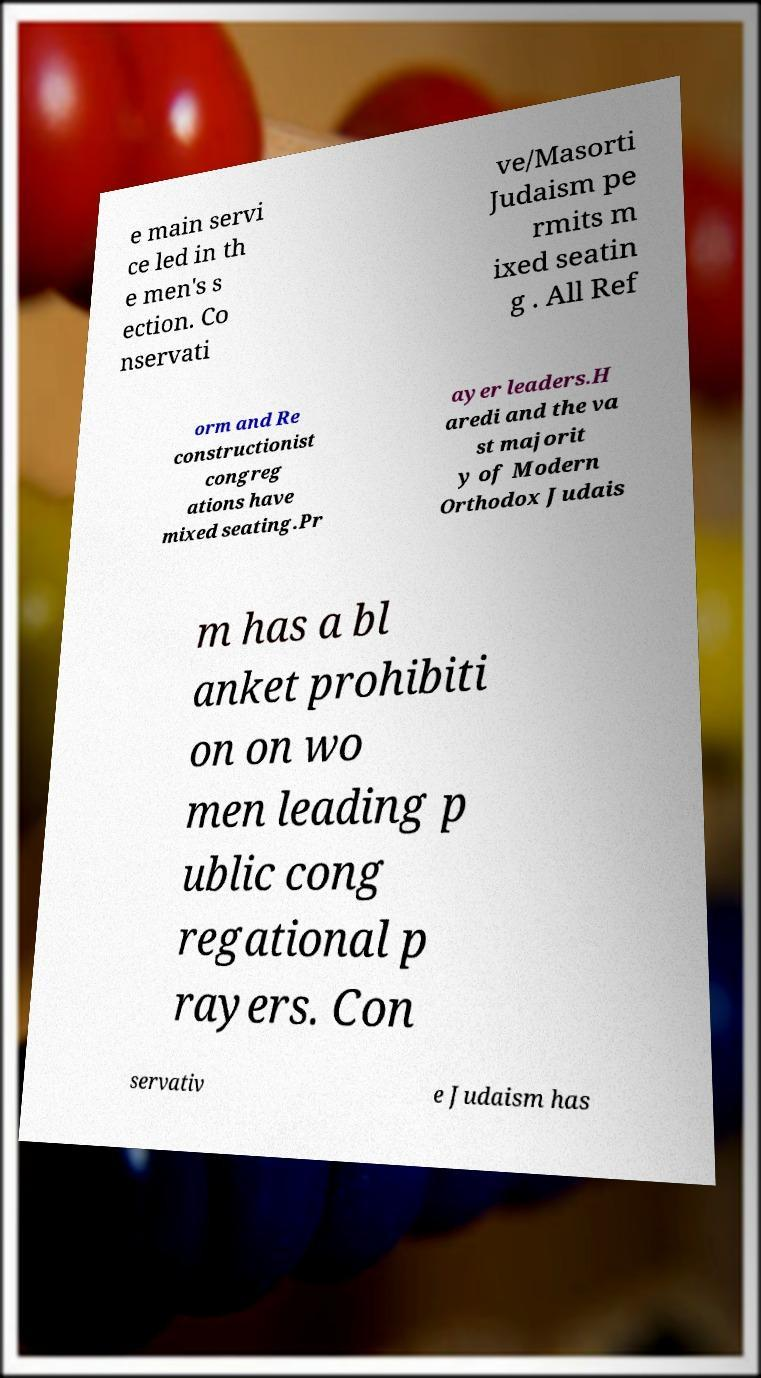Please identify and transcribe the text found in this image. e main servi ce led in th e men's s ection. Co nservati ve/Masorti Judaism pe rmits m ixed seatin g . All Ref orm and Re constructionist congreg ations have mixed seating.Pr ayer leaders.H aredi and the va st majorit y of Modern Orthodox Judais m has a bl anket prohibiti on on wo men leading p ublic cong regational p rayers. Con servativ e Judaism has 